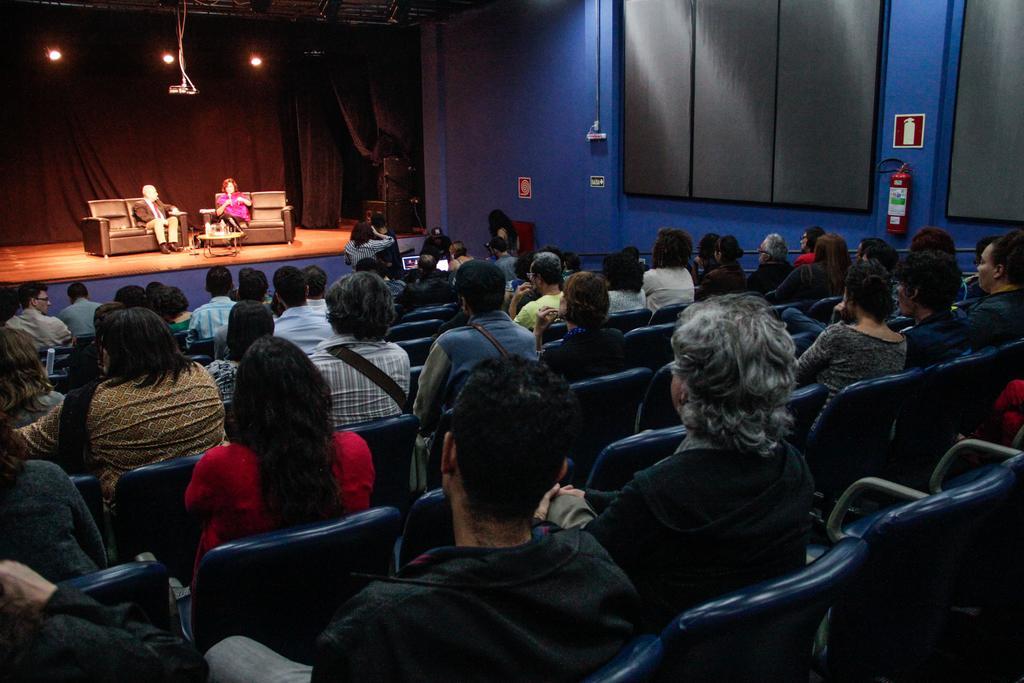How would you summarize this image in a sentence or two? In the center of the image there are people sitting on chairs. In the background of the image there two people sitting on chairs on the stage. There is a black color cloth. There is wall. 